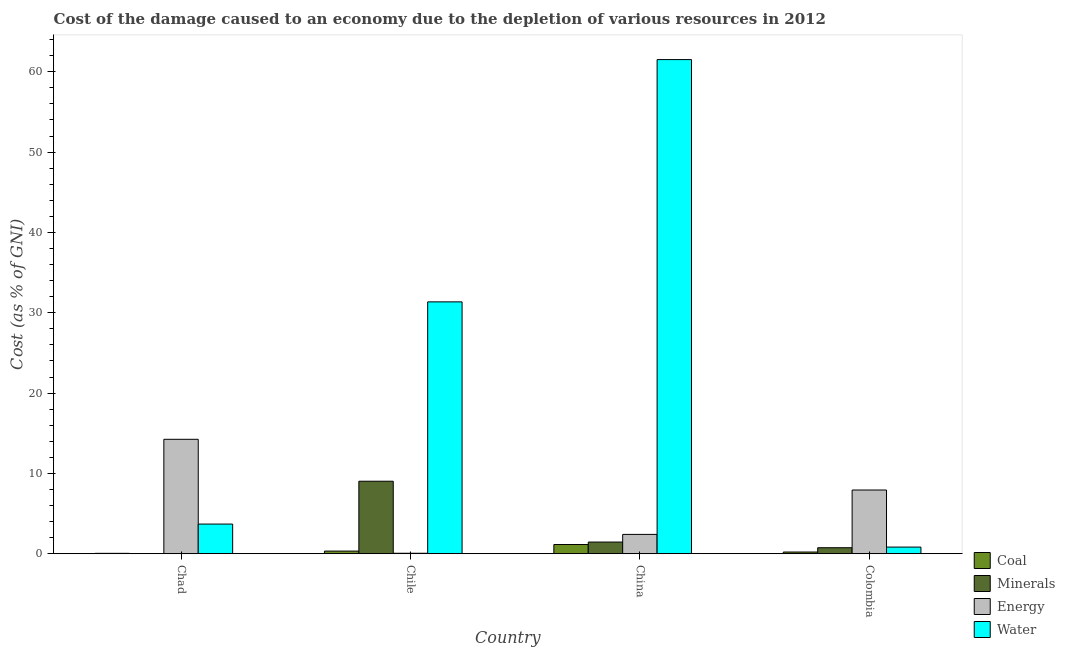How many groups of bars are there?
Provide a succinct answer. 4. Are the number of bars per tick equal to the number of legend labels?
Provide a succinct answer. Yes. Are the number of bars on each tick of the X-axis equal?
Offer a terse response. Yes. How many bars are there on the 4th tick from the right?
Offer a very short reply. 4. What is the label of the 4th group of bars from the left?
Provide a short and direct response. Colombia. In how many cases, is the number of bars for a given country not equal to the number of legend labels?
Offer a very short reply. 0. What is the cost of damage due to depletion of coal in Chile?
Your answer should be very brief. 0.33. Across all countries, what is the maximum cost of damage due to depletion of minerals?
Provide a succinct answer. 9.03. Across all countries, what is the minimum cost of damage due to depletion of water?
Ensure brevity in your answer.  0.83. In which country was the cost of damage due to depletion of water maximum?
Offer a very short reply. China. In which country was the cost of damage due to depletion of energy minimum?
Keep it short and to the point. Chile. What is the total cost of damage due to depletion of coal in the graph?
Your response must be concise. 1.74. What is the difference between the cost of damage due to depletion of coal in Chad and that in Chile?
Make the answer very short. -0.28. What is the difference between the cost of damage due to depletion of energy in China and the cost of damage due to depletion of water in Colombia?
Provide a short and direct response. 1.58. What is the average cost of damage due to depletion of energy per country?
Your response must be concise. 6.16. What is the difference between the cost of damage due to depletion of energy and cost of damage due to depletion of water in Chad?
Make the answer very short. 10.55. In how many countries, is the cost of damage due to depletion of minerals greater than 46 %?
Give a very brief answer. 0. What is the ratio of the cost of damage due to depletion of coal in Chad to that in Chile?
Provide a succinct answer. 0.15. What is the difference between the highest and the second highest cost of damage due to depletion of coal?
Keep it short and to the point. 0.82. What is the difference between the highest and the lowest cost of damage due to depletion of energy?
Your answer should be compact. 14.19. Is it the case that in every country, the sum of the cost of damage due to depletion of water and cost of damage due to depletion of minerals is greater than the sum of cost of damage due to depletion of energy and cost of damage due to depletion of coal?
Ensure brevity in your answer.  No. What does the 1st bar from the left in Chile represents?
Provide a succinct answer. Coal. What does the 3rd bar from the right in China represents?
Provide a short and direct response. Minerals. Is it the case that in every country, the sum of the cost of damage due to depletion of coal and cost of damage due to depletion of minerals is greater than the cost of damage due to depletion of energy?
Provide a succinct answer. No. Are all the bars in the graph horizontal?
Give a very brief answer. No. What is the difference between two consecutive major ticks on the Y-axis?
Offer a terse response. 10. Are the values on the major ticks of Y-axis written in scientific E-notation?
Provide a succinct answer. No. Does the graph contain any zero values?
Provide a short and direct response. No. Does the graph contain grids?
Your answer should be very brief. No. Where does the legend appear in the graph?
Provide a short and direct response. Bottom right. How many legend labels are there?
Your answer should be compact. 4. What is the title of the graph?
Make the answer very short. Cost of the damage caused to an economy due to the depletion of various resources in 2012 . What is the label or title of the X-axis?
Your answer should be compact. Country. What is the label or title of the Y-axis?
Your response must be concise. Cost (as % of GNI). What is the Cost (as % of GNI) of Coal in Chad?
Ensure brevity in your answer.  0.05. What is the Cost (as % of GNI) in Minerals in Chad?
Give a very brief answer. 0.03. What is the Cost (as % of GNI) in Energy in Chad?
Provide a succinct answer. 14.25. What is the Cost (as % of GNI) in Water in Chad?
Provide a short and direct response. 3.69. What is the Cost (as % of GNI) of Coal in Chile?
Your response must be concise. 0.33. What is the Cost (as % of GNI) of Minerals in Chile?
Offer a very short reply. 9.03. What is the Cost (as % of GNI) in Energy in Chile?
Keep it short and to the point. 0.06. What is the Cost (as % of GNI) of Water in Chile?
Provide a succinct answer. 31.36. What is the Cost (as % of GNI) of Coal in China?
Your answer should be very brief. 1.15. What is the Cost (as % of GNI) in Minerals in China?
Make the answer very short. 1.45. What is the Cost (as % of GNI) in Energy in China?
Keep it short and to the point. 2.41. What is the Cost (as % of GNI) in Water in China?
Your answer should be compact. 61.52. What is the Cost (as % of GNI) of Coal in Colombia?
Ensure brevity in your answer.  0.21. What is the Cost (as % of GNI) in Minerals in Colombia?
Give a very brief answer. 0.75. What is the Cost (as % of GNI) in Energy in Colombia?
Provide a succinct answer. 7.93. What is the Cost (as % of GNI) in Water in Colombia?
Your response must be concise. 0.83. Across all countries, what is the maximum Cost (as % of GNI) in Coal?
Provide a succinct answer. 1.15. Across all countries, what is the maximum Cost (as % of GNI) of Minerals?
Keep it short and to the point. 9.03. Across all countries, what is the maximum Cost (as % of GNI) of Energy?
Your response must be concise. 14.25. Across all countries, what is the maximum Cost (as % of GNI) of Water?
Make the answer very short. 61.52. Across all countries, what is the minimum Cost (as % of GNI) in Coal?
Offer a very short reply. 0.05. Across all countries, what is the minimum Cost (as % of GNI) in Minerals?
Make the answer very short. 0.03. Across all countries, what is the minimum Cost (as % of GNI) of Energy?
Offer a very short reply. 0.06. Across all countries, what is the minimum Cost (as % of GNI) in Water?
Ensure brevity in your answer.  0.83. What is the total Cost (as % of GNI) in Coal in the graph?
Make the answer very short. 1.74. What is the total Cost (as % of GNI) in Minerals in the graph?
Give a very brief answer. 11.26. What is the total Cost (as % of GNI) of Energy in the graph?
Your answer should be very brief. 24.65. What is the total Cost (as % of GNI) in Water in the graph?
Offer a very short reply. 97.4. What is the difference between the Cost (as % of GNI) of Coal in Chad and that in Chile?
Keep it short and to the point. -0.28. What is the difference between the Cost (as % of GNI) in Minerals in Chad and that in Chile?
Your answer should be compact. -9. What is the difference between the Cost (as % of GNI) of Energy in Chad and that in Chile?
Your response must be concise. 14.19. What is the difference between the Cost (as % of GNI) of Water in Chad and that in Chile?
Give a very brief answer. -27.66. What is the difference between the Cost (as % of GNI) in Coal in Chad and that in China?
Ensure brevity in your answer.  -1.1. What is the difference between the Cost (as % of GNI) of Minerals in Chad and that in China?
Your answer should be very brief. -1.43. What is the difference between the Cost (as % of GNI) in Energy in Chad and that in China?
Keep it short and to the point. 11.84. What is the difference between the Cost (as % of GNI) of Water in Chad and that in China?
Offer a very short reply. -57.83. What is the difference between the Cost (as % of GNI) in Coal in Chad and that in Colombia?
Offer a terse response. -0.16. What is the difference between the Cost (as % of GNI) in Minerals in Chad and that in Colombia?
Offer a very short reply. -0.72. What is the difference between the Cost (as % of GNI) in Energy in Chad and that in Colombia?
Your answer should be very brief. 6.31. What is the difference between the Cost (as % of GNI) in Water in Chad and that in Colombia?
Offer a very short reply. 2.87. What is the difference between the Cost (as % of GNI) of Coal in Chile and that in China?
Provide a succinct answer. -0.82. What is the difference between the Cost (as % of GNI) of Minerals in Chile and that in China?
Give a very brief answer. 7.57. What is the difference between the Cost (as % of GNI) of Energy in Chile and that in China?
Give a very brief answer. -2.35. What is the difference between the Cost (as % of GNI) of Water in Chile and that in China?
Give a very brief answer. -30.16. What is the difference between the Cost (as % of GNI) in Coal in Chile and that in Colombia?
Ensure brevity in your answer.  0.12. What is the difference between the Cost (as % of GNI) of Minerals in Chile and that in Colombia?
Offer a very short reply. 8.28. What is the difference between the Cost (as % of GNI) in Energy in Chile and that in Colombia?
Keep it short and to the point. -7.88. What is the difference between the Cost (as % of GNI) of Water in Chile and that in Colombia?
Offer a terse response. 30.53. What is the difference between the Cost (as % of GNI) in Coal in China and that in Colombia?
Make the answer very short. 0.94. What is the difference between the Cost (as % of GNI) of Minerals in China and that in Colombia?
Provide a succinct answer. 0.71. What is the difference between the Cost (as % of GNI) in Energy in China and that in Colombia?
Offer a terse response. -5.53. What is the difference between the Cost (as % of GNI) in Water in China and that in Colombia?
Offer a terse response. 60.69. What is the difference between the Cost (as % of GNI) in Coal in Chad and the Cost (as % of GNI) in Minerals in Chile?
Provide a short and direct response. -8.98. What is the difference between the Cost (as % of GNI) in Coal in Chad and the Cost (as % of GNI) in Energy in Chile?
Provide a short and direct response. -0.01. What is the difference between the Cost (as % of GNI) of Coal in Chad and the Cost (as % of GNI) of Water in Chile?
Provide a succinct answer. -31.31. What is the difference between the Cost (as % of GNI) of Minerals in Chad and the Cost (as % of GNI) of Energy in Chile?
Offer a terse response. -0.03. What is the difference between the Cost (as % of GNI) in Minerals in Chad and the Cost (as % of GNI) in Water in Chile?
Offer a terse response. -31.33. What is the difference between the Cost (as % of GNI) of Energy in Chad and the Cost (as % of GNI) of Water in Chile?
Offer a terse response. -17.11. What is the difference between the Cost (as % of GNI) of Coal in Chad and the Cost (as % of GNI) of Minerals in China?
Ensure brevity in your answer.  -1.41. What is the difference between the Cost (as % of GNI) of Coal in Chad and the Cost (as % of GNI) of Energy in China?
Give a very brief answer. -2.36. What is the difference between the Cost (as % of GNI) of Coal in Chad and the Cost (as % of GNI) of Water in China?
Your answer should be very brief. -61.47. What is the difference between the Cost (as % of GNI) of Minerals in Chad and the Cost (as % of GNI) of Energy in China?
Make the answer very short. -2.38. What is the difference between the Cost (as % of GNI) of Minerals in Chad and the Cost (as % of GNI) of Water in China?
Your answer should be very brief. -61.49. What is the difference between the Cost (as % of GNI) in Energy in Chad and the Cost (as % of GNI) in Water in China?
Keep it short and to the point. -47.27. What is the difference between the Cost (as % of GNI) in Coal in Chad and the Cost (as % of GNI) in Minerals in Colombia?
Keep it short and to the point. -0.7. What is the difference between the Cost (as % of GNI) of Coal in Chad and the Cost (as % of GNI) of Energy in Colombia?
Your answer should be compact. -7.89. What is the difference between the Cost (as % of GNI) in Coal in Chad and the Cost (as % of GNI) in Water in Colombia?
Make the answer very short. -0.78. What is the difference between the Cost (as % of GNI) in Minerals in Chad and the Cost (as % of GNI) in Energy in Colombia?
Your answer should be compact. -7.91. What is the difference between the Cost (as % of GNI) in Minerals in Chad and the Cost (as % of GNI) in Water in Colombia?
Offer a terse response. -0.8. What is the difference between the Cost (as % of GNI) in Energy in Chad and the Cost (as % of GNI) in Water in Colombia?
Your answer should be very brief. 13.42. What is the difference between the Cost (as % of GNI) of Coal in Chile and the Cost (as % of GNI) of Minerals in China?
Give a very brief answer. -1.12. What is the difference between the Cost (as % of GNI) of Coal in Chile and the Cost (as % of GNI) of Energy in China?
Offer a terse response. -2.08. What is the difference between the Cost (as % of GNI) in Coal in Chile and the Cost (as % of GNI) in Water in China?
Keep it short and to the point. -61.19. What is the difference between the Cost (as % of GNI) of Minerals in Chile and the Cost (as % of GNI) of Energy in China?
Your answer should be very brief. 6.62. What is the difference between the Cost (as % of GNI) of Minerals in Chile and the Cost (as % of GNI) of Water in China?
Make the answer very short. -52.49. What is the difference between the Cost (as % of GNI) of Energy in Chile and the Cost (as % of GNI) of Water in China?
Offer a terse response. -61.46. What is the difference between the Cost (as % of GNI) in Coal in Chile and the Cost (as % of GNI) in Minerals in Colombia?
Make the answer very short. -0.42. What is the difference between the Cost (as % of GNI) of Coal in Chile and the Cost (as % of GNI) of Energy in Colombia?
Keep it short and to the point. -7.61. What is the difference between the Cost (as % of GNI) of Coal in Chile and the Cost (as % of GNI) of Water in Colombia?
Give a very brief answer. -0.5. What is the difference between the Cost (as % of GNI) of Minerals in Chile and the Cost (as % of GNI) of Energy in Colombia?
Offer a very short reply. 1.09. What is the difference between the Cost (as % of GNI) in Minerals in Chile and the Cost (as % of GNI) in Water in Colombia?
Offer a very short reply. 8.2. What is the difference between the Cost (as % of GNI) of Energy in Chile and the Cost (as % of GNI) of Water in Colombia?
Your answer should be compact. -0.77. What is the difference between the Cost (as % of GNI) of Coal in China and the Cost (as % of GNI) of Minerals in Colombia?
Make the answer very short. 0.4. What is the difference between the Cost (as % of GNI) of Coal in China and the Cost (as % of GNI) of Energy in Colombia?
Keep it short and to the point. -6.79. What is the difference between the Cost (as % of GNI) in Coal in China and the Cost (as % of GNI) in Water in Colombia?
Offer a very short reply. 0.32. What is the difference between the Cost (as % of GNI) of Minerals in China and the Cost (as % of GNI) of Energy in Colombia?
Make the answer very short. -6.48. What is the difference between the Cost (as % of GNI) in Minerals in China and the Cost (as % of GNI) in Water in Colombia?
Offer a very short reply. 0.63. What is the difference between the Cost (as % of GNI) in Energy in China and the Cost (as % of GNI) in Water in Colombia?
Your answer should be compact. 1.58. What is the average Cost (as % of GNI) in Coal per country?
Keep it short and to the point. 0.43. What is the average Cost (as % of GNI) of Minerals per country?
Your answer should be compact. 2.81. What is the average Cost (as % of GNI) of Energy per country?
Your response must be concise. 6.16. What is the average Cost (as % of GNI) of Water per country?
Your answer should be very brief. 24.35. What is the difference between the Cost (as % of GNI) in Coal and Cost (as % of GNI) in Minerals in Chad?
Your response must be concise. 0.02. What is the difference between the Cost (as % of GNI) in Coal and Cost (as % of GNI) in Energy in Chad?
Give a very brief answer. -14.2. What is the difference between the Cost (as % of GNI) of Coal and Cost (as % of GNI) of Water in Chad?
Your response must be concise. -3.64. What is the difference between the Cost (as % of GNI) in Minerals and Cost (as % of GNI) in Energy in Chad?
Keep it short and to the point. -14.22. What is the difference between the Cost (as % of GNI) in Minerals and Cost (as % of GNI) in Water in Chad?
Ensure brevity in your answer.  -3.67. What is the difference between the Cost (as % of GNI) in Energy and Cost (as % of GNI) in Water in Chad?
Provide a succinct answer. 10.55. What is the difference between the Cost (as % of GNI) of Coal and Cost (as % of GNI) of Minerals in Chile?
Offer a terse response. -8.7. What is the difference between the Cost (as % of GNI) in Coal and Cost (as % of GNI) in Energy in Chile?
Provide a short and direct response. 0.27. What is the difference between the Cost (as % of GNI) of Coal and Cost (as % of GNI) of Water in Chile?
Your answer should be compact. -31.03. What is the difference between the Cost (as % of GNI) of Minerals and Cost (as % of GNI) of Energy in Chile?
Make the answer very short. 8.97. What is the difference between the Cost (as % of GNI) in Minerals and Cost (as % of GNI) in Water in Chile?
Make the answer very short. -22.33. What is the difference between the Cost (as % of GNI) of Energy and Cost (as % of GNI) of Water in Chile?
Give a very brief answer. -31.3. What is the difference between the Cost (as % of GNI) of Coal and Cost (as % of GNI) of Minerals in China?
Give a very brief answer. -0.31. What is the difference between the Cost (as % of GNI) of Coal and Cost (as % of GNI) of Energy in China?
Offer a very short reply. -1.26. What is the difference between the Cost (as % of GNI) in Coal and Cost (as % of GNI) in Water in China?
Provide a succinct answer. -60.37. What is the difference between the Cost (as % of GNI) of Minerals and Cost (as % of GNI) of Energy in China?
Give a very brief answer. -0.95. What is the difference between the Cost (as % of GNI) of Minerals and Cost (as % of GNI) of Water in China?
Your answer should be very brief. -60.07. What is the difference between the Cost (as % of GNI) of Energy and Cost (as % of GNI) of Water in China?
Give a very brief answer. -59.11. What is the difference between the Cost (as % of GNI) in Coal and Cost (as % of GNI) in Minerals in Colombia?
Your answer should be very brief. -0.54. What is the difference between the Cost (as % of GNI) in Coal and Cost (as % of GNI) in Energy in Colombia?
Make the answer very short. -7.72. What is the difference between the Cost (as % of GNI) of Coal and Cost (as % of GNI) of Water in Colombia?
Offer a very short reply. -0.61. What is the difference between the Cost (as % of GNI) in Minerals and Cost (as % of GNI) in Energy in Colombia?
Give a very brief answer. -7.19. What is the difference between the Cost (as % of GNI) in Minerals and Cost (as % of GNI) in Water in Colombia?
Ensure brevity in your answer.  -0.08. What is the difference between the Cost (as % of GNI) in Energy and Cost (as % of GNI) in Water in Colombia?
Offer a terse response. 7.11. What is the ratio of the Cost (as % of GNI) of Coal in Chad to that in Chile?
Provide a short and direct response. 0.15. What is the ratio of the Cost (as % of GNI) in Minerals in Chad to that in Chile?
Provide a succinct answer. 0. What is the ratio of the Cost (as % of GNI) of Energy in Chad to that in Chile?
Provide a succinct answer. 243.71. What is the ratio of the Cost (as % of GNI) in Water in Chad to that in Chile?
Keep it short and to the point. 0.12. What is the ratio of the Cost (as % of GNI) of Coal in Chad to that in China?
Provide a short and direct response. 0.04. What is the ratio of the Cost (as % of GNI) in Minerals in Chad to that in China?
Keep it short and to the point. 0.02. What is the ratio of the Cost (as % of GNI) of Energy in Chad to that in China?
Provide a succinct answer. 5.92. What is the ratio of the Cost (as % of GNI) of Coal in Chad to that in Colombia?
Keep it short and to the point. 0.23. What is the ratio of the Cost (as % of GNI) of Minerals in Chad to that in Colombia?
Keep it short and to the point. 0.04. What is the ratio of the Cost (as % of GNI) in Energy in Chad to that in Colombia?
Ensure brevity in your answer.  1.8. What is the ratio of the Cost (as % of GNI) in Water in Chad to that in Colombia?
Ensure brevity in your answer.  4.47. What is the ratio of the Cost (as % of GNI) in Coal in Chile to that in China?
Your answer should be compact. 0.29. What is the ratio of the Cost (as % of GNI) of Minerals in Chile to that in China?
Your answer should be very brief. 6.21. What is the ratio of the Cost (as % of GNI) in Energy in Chile to that in China?
Give a very brief answer. 0.02. What is the ratio of the Cost (as % of GNI) of Water in Chile to that in China?
Provide a short and direct response. 0.51. What is the ratio of the Cost (as % of GNI) in Coal in Chile to that in Colombia?
Offer a very short reply. 1.55. What is the ratio of the Cost (as % of GNI) of Minerals in Chile to that in Colombia?
Offer a very short reply. 12.07. What is the ratio of the Cost (as % of GNI) in Energy in Chile to that in Colombia?
Offer a terse response. 0.01. What is the ratio of the Cost (as % of GNI) of Water in Chile to that in Colombia?
Offer a very short reply. 37.95. What is the ratio of the Cost (as % of GNI) in Coal in China to that in Colombia?
Offer a very short reply. 5.42. What is the ratio of the Cost (as % of GNI) in Minerals in China to that in Colombia?
Provide a succinct answer. 1.94. What is the ratio of the Cost (as % of GNI) of Energy in China to that in Colombia?
Your response must be concise. 0.3. What is the ratio of the Cost (as % of GNI) of Water in China to that in Colombia?
Provide a short and direct response. 74.45. What is the difference between the highest and the second highest Cost (as % of GNI) of Coal?
Offer a terse response. 0.82. What is the difference between the highest and the second highest Cost (as % of GNI) in Minerals?
Provide a succinct answer. 7.57. What is the difference between the highest and the second highest Cost (as % of GNI) in Energy?
Your answer should be compact. 6.31. What is the difference between the highest and the second highest Cost (as % of GNI) in Water?
Keep it short and to the point. 30.16. What is the difference between the highest and the lowest Cost (as % of GNI) of Coal?
Ensure brevity in your answer.  1.1. What is the difference between the highest and the lowest Cost (as % of GNI) in Minerals?
Your answer should be compact. 9. What is the difference between the highest and the lowest Cost (as % of GNI) in Energy?
Make the answer very short. 14.19. What is the difference between the highest and the lowest Cost (as % of GNI) in Water?
Give a very brief answer. 60.69. 